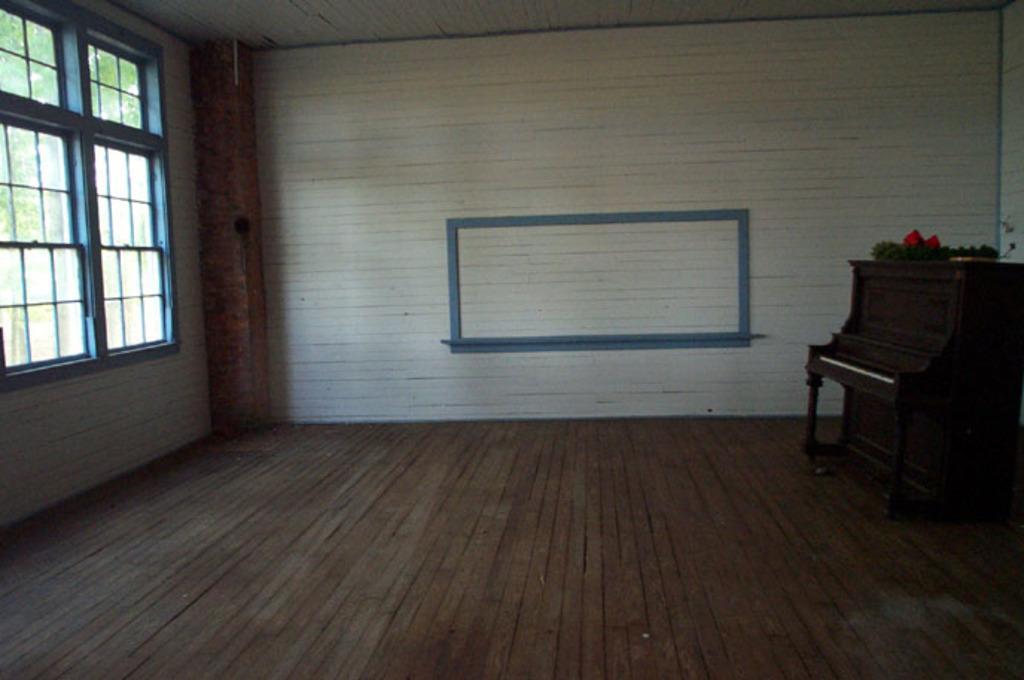Please provide a concise description of this image. Here we can see a room and there is a piano on the right side and at the left side we can see a window present 